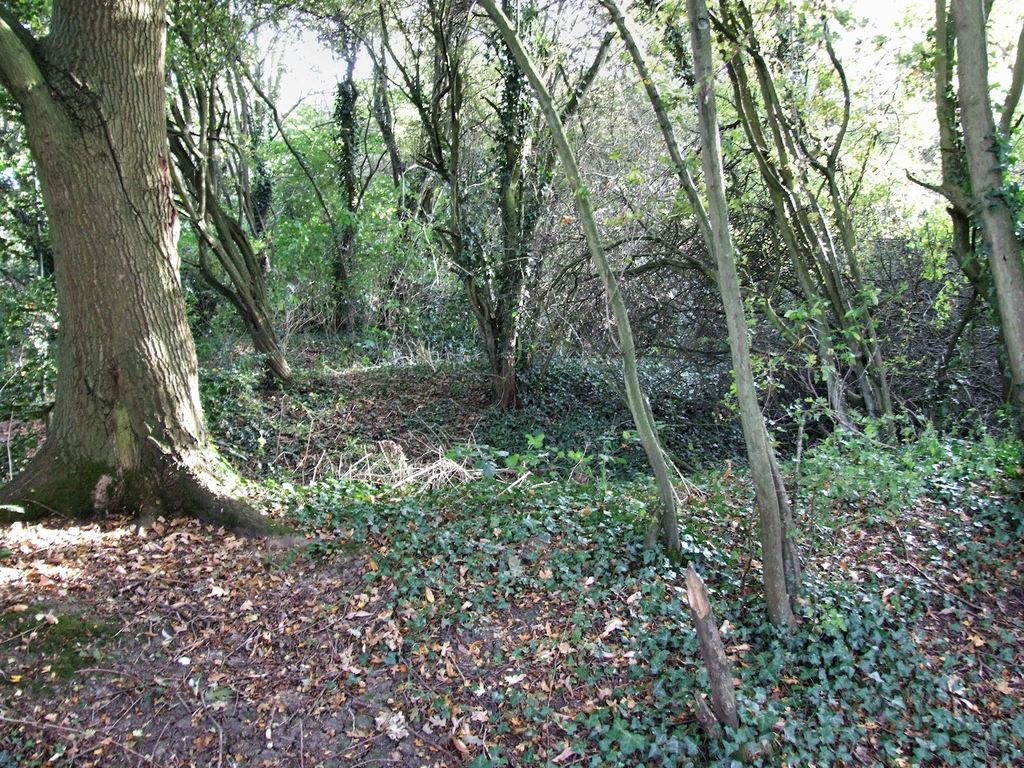What is located on the left side of the image? There is a tree trunk on the left side of the image. What can be seen in the background of the image? There are trees with green leaves in the background of the image. What is covering the ground in the image? Dry leaves and sand are visible on the ground. What type of industry is depicted in the image? There is no industry depicted in the image; it features a tree trunk, trees with green leaves, dry leaves, and sand. What selection process is being shown in the image? There is no selection process being shown in the image; it is a natural scene with trees and leaves. 